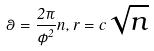<formula> <loc_0><loc_0><loc_500><loc_500>\theta = \frac { 2 \pi } { \phi ^ { 2 } } n , r = c \sqrt { n }</formula> 